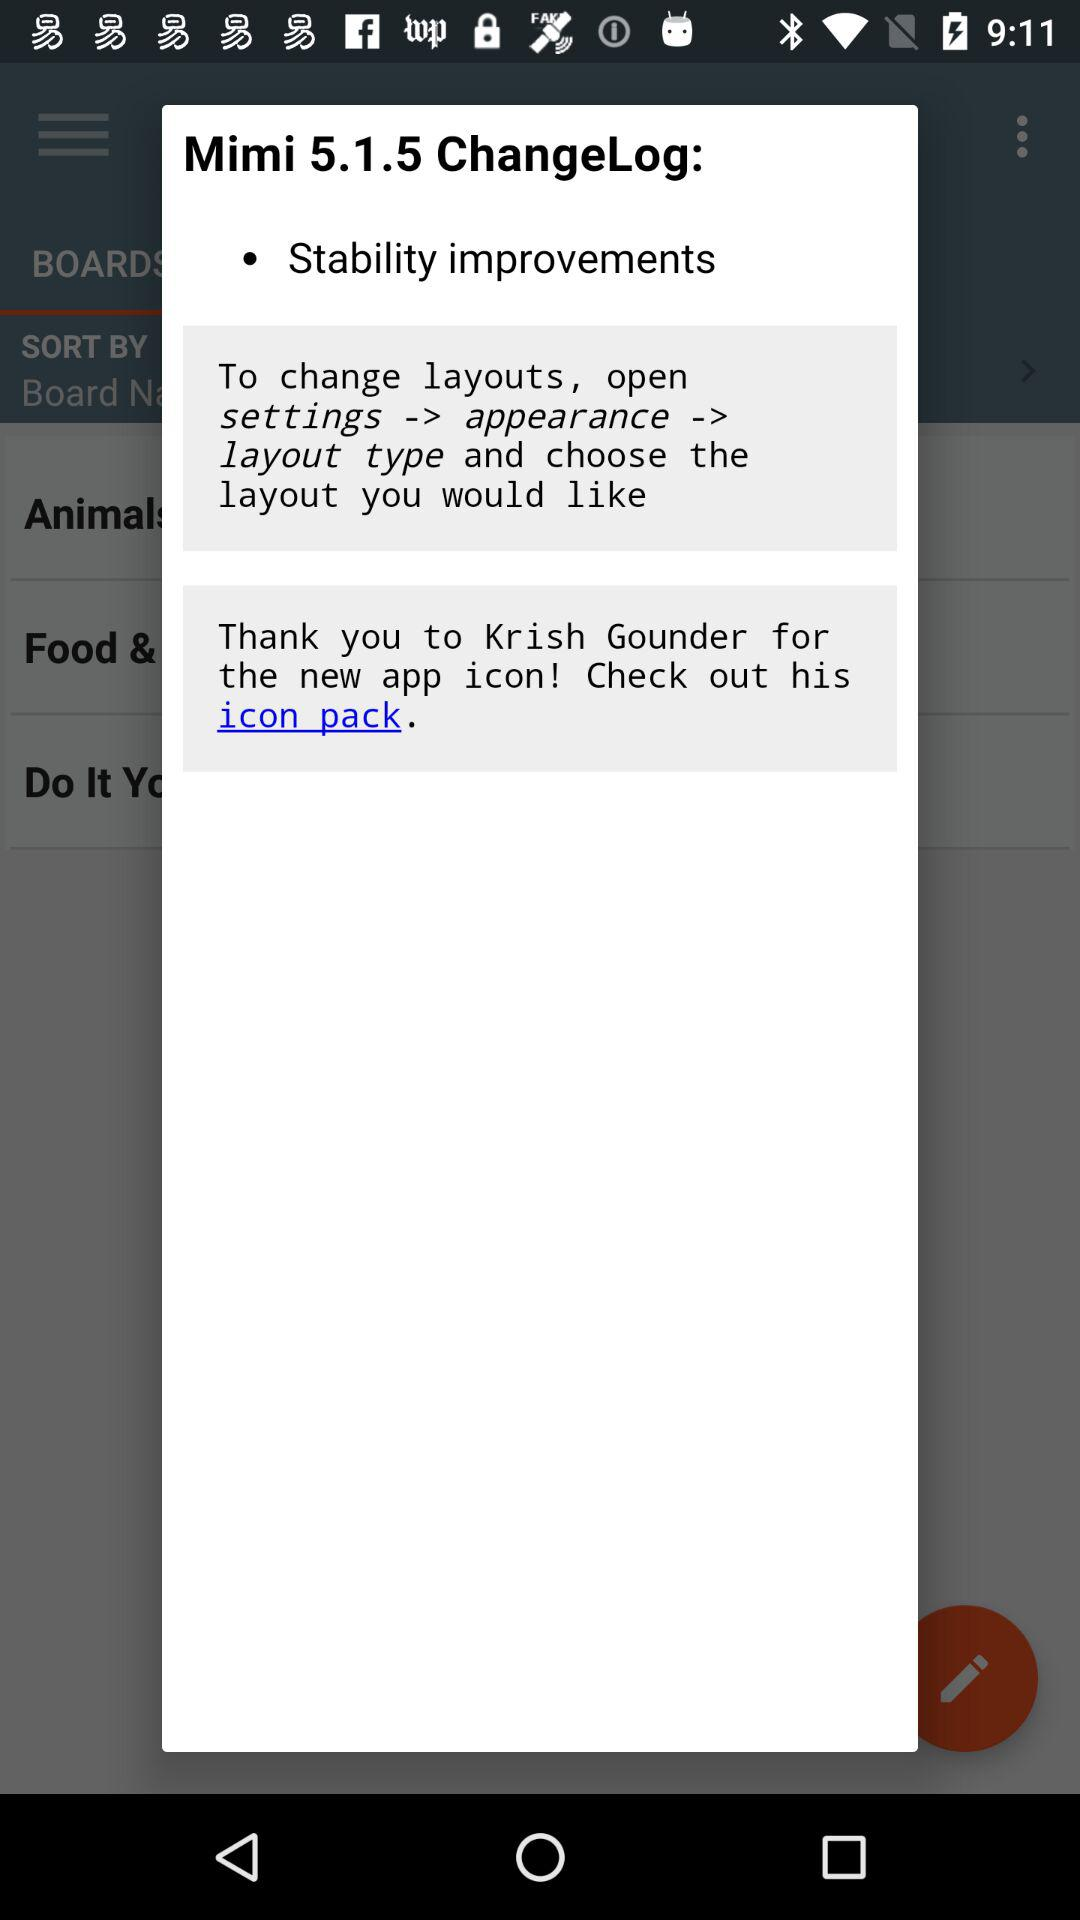What is the version of "Mimi"? The version is 5.1.5. 